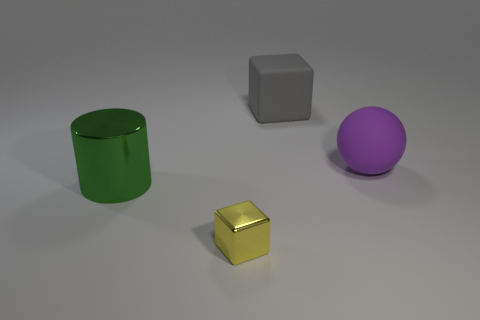Subtract all cylinders. How many objects are left? 3 Subtract all purple cylinders. How many gray blocks are left? 1 Add 4 gray matte objects. How many gray matte objects are left? 5 Add 4 green metallic cylinders. How many green metallic cylinders exist? 5 Add 3 rubber blocks. How many objects exist? 7 Subtract 0 blue spheres. How many objects are left? 4 Subtract 1 cylinders. How many cylinders are left? 0 Subtract all blue blocks. Subtract all cyan spheres. How many blocks are left? 2 Subtract all green cylinders. Subtract all purple metal balls. How many objects are left? 3 